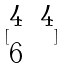Convert formula to latex. <formula><loc_0><loc_0><loc_500><loc_500>[ \begin{matrix} 4 & 4 \\ 6 \end{matrix} ]</formula> 